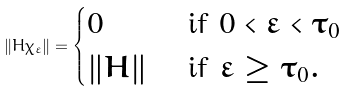Convert formula to latex. <formula><loc_0><loc_0><loc_500><loc_500>\| H \chi _ { \varepsilon } \| = \begin{cases} 0 & \text { if } 0 < \varepsilon < \tau _ { 0 } \\ \| H \| & \text { if } \varepsilon \geq \tau _ { 0 } . \end{cases}</formula> 